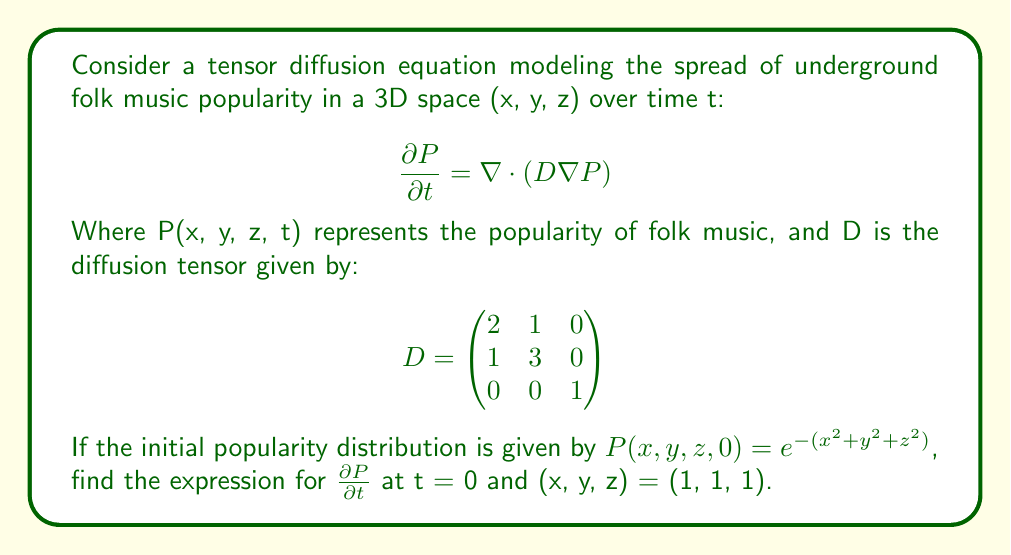What is the answer to this math problem? To solve this problem, we'll follow these steps:

1) The tensor diffusion equation is given by:
   $$\frac{\partial P}{\partial t} = \nabla \cdot (D \nabla P)$$

2) We need to calculate $\nabla P$ and then $D \nabla P$:
   
   $\nabla P = (\frac{\partial P}{\partial x}, \frac{\partial P}{\partial y}, \frac{\partial P}{\partial z})$
   
   At t = 0: $P(x, y, z, 0) = e^{-(x^2 + y^2 + z^2)}$
   
   $\frac{\partial P}{\partial x} = -2xe^{-(x^2 + y^2 + z^2)}$
   $\frac{\partial P}{\partial y} = -2ye^{-(x^2 + y^2 + z^2)}$
   $\frac{\partial P}{\partial z} = -2ze^{-(x^2 + y^2 + z^2)}$

3) Now, let's calculate $D \nabla P$:
   $$D \nabla P = \begin{pmatrix}
   2 & 1 & 0 \\
   1 & 3 & 0 \\
   0 & 0 & 1
   \end{pmatrix} \begin{pmatrix}
   -2xe^{-(x^2 + y^2 + z^2)} \\
   -2ye^{-(x^2 + y^2 + z^2)} \\
   -2ze^{-(x^2 + y^2 + z^2)}
   \end{pmatrix}$$

   $$= \begin{pmatrix}
   -4xe^{-(x^2 + y^2 + z^2)} - 2ye^{-(x^2 + y^2 + z^2)} \\
   -2xe^{-(x^2 + y^2 + z^2)} - 6ye^{-(x^2 + y^2 + z^2)} \\
   -2ze^{-(x^2 + y^2 + z^2)}
   \end{pmatrix}$$

4) Now we need to calculate $\nabla \cdot (D \nabla P)$:
   
   $$\nabla \cdot (D \nabla P) = \frac{\partial}{\partial x}(-4xe^{-(x^2 + y^2 + z^2)} - 2ye^{-(x^2 + y^2 + z^2)}) + \\
   \frac{\partial}{\partial y}(-2xe^{-(x^2 + y^2 + z^2)} - 6ye^{-(x^2 + y^2 + z^2)}) + \\
   \frac{\partial}{\partial z}(-2ze^{-(x^2 + y^2 + z^2)})$$

5) Calculating each term:
   
   $\frac{\partial}{\partial x}(-4xe^{-(x^2 + y^2 + z^2)} - 2ye^{-(x^2 + y^2 + z^2)}) = (-4 + 8x^2)e^{-(x^2 + y^2 + z^2)} + 4xye^{-(x^2 + y^2 + z^2)}$
   
   $\frac{\partial}{\partial y}(-2xe^{-(x^2 + y^2 + z^2)} - 6ye^{-(x^2 + y^2 + z^2)}) = 4xye^{-(x^2 + y^2 + z^2)} + (-6 + 12y^2)e^{-(x^2 + y^2 + z^2)}$
   
   $\frac{\partial}{\partial z}(-2ze^{-(x^2 + y^2 + z^2)}) = (-2 + 4z^2)e^{-(x^2 + y^2 + z^2)}$

6) Summing these terms:
   
   $$\frac{\partial P}{\partial t} = (8x^2 + 12y^2 + 4z^2 - 12 + 8xy)e^{-(x^2 + y^2 + z^2)}$$

7) Evaluating at (x, y, z) = (1, 1, 1):
   
   $$\frac{\partial P}{\partial t} = (8 + 12 + 4 - 12 + 8)e^{-3} = 20e^{-3}$$
Answer: $20e^{-3}$ 